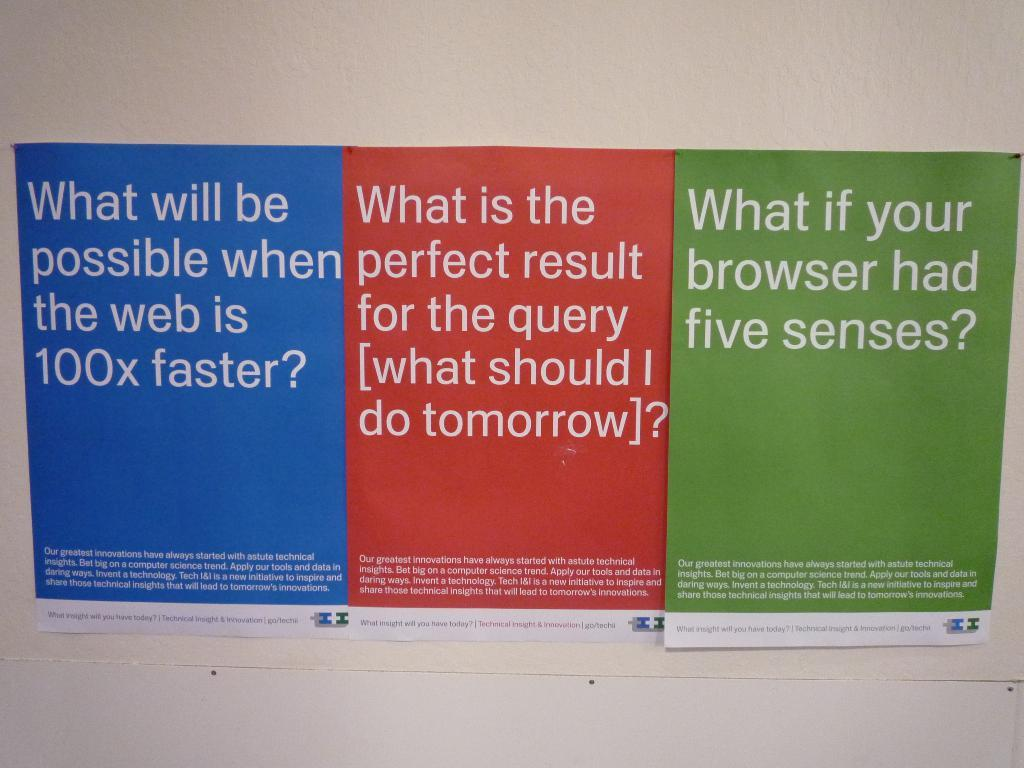<image>
Give a short and clear explanation of the subsequent image. Three pamphlets discussing the web and browsers prepared by Technical Insight & Innovation 